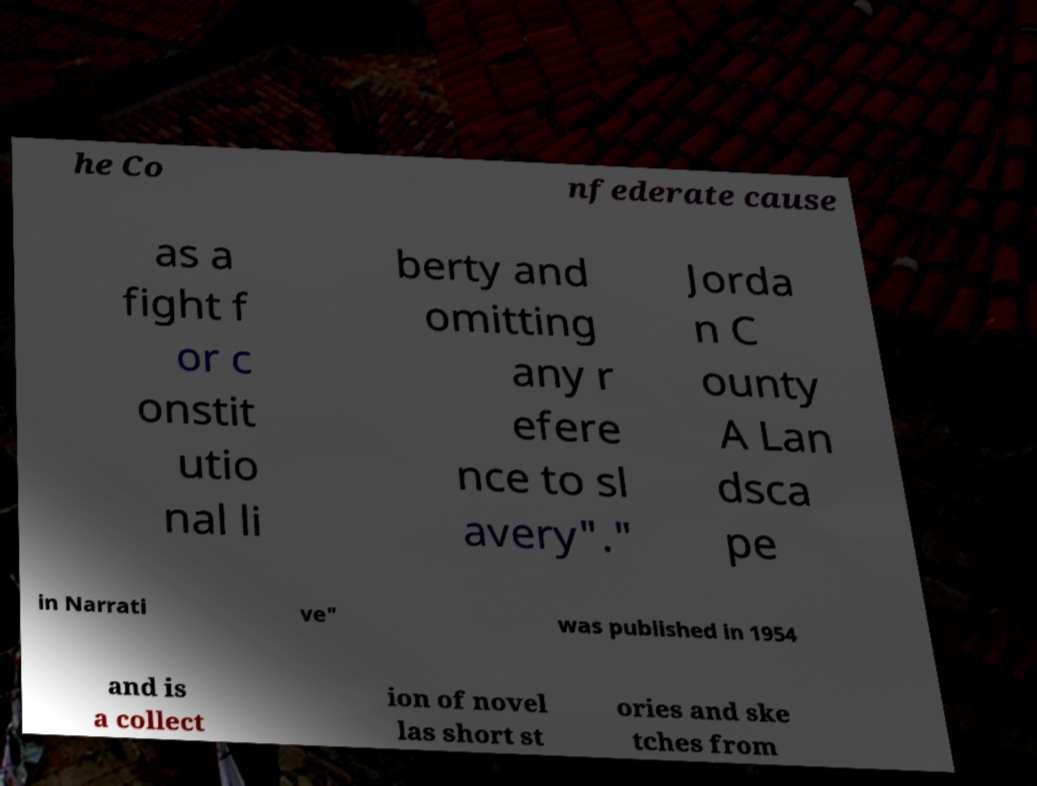I need the written content from this picture converted into text. Can you do that? he Co nfederate cause as a fight f or c onstit utio nal li berty and omitting any r efere nce to sl avery"." Jorda n C ounty A Lan dsca pe in Narrati ve" was published in 1954 and is a collect ion of novel las short st ories and ske tches from 